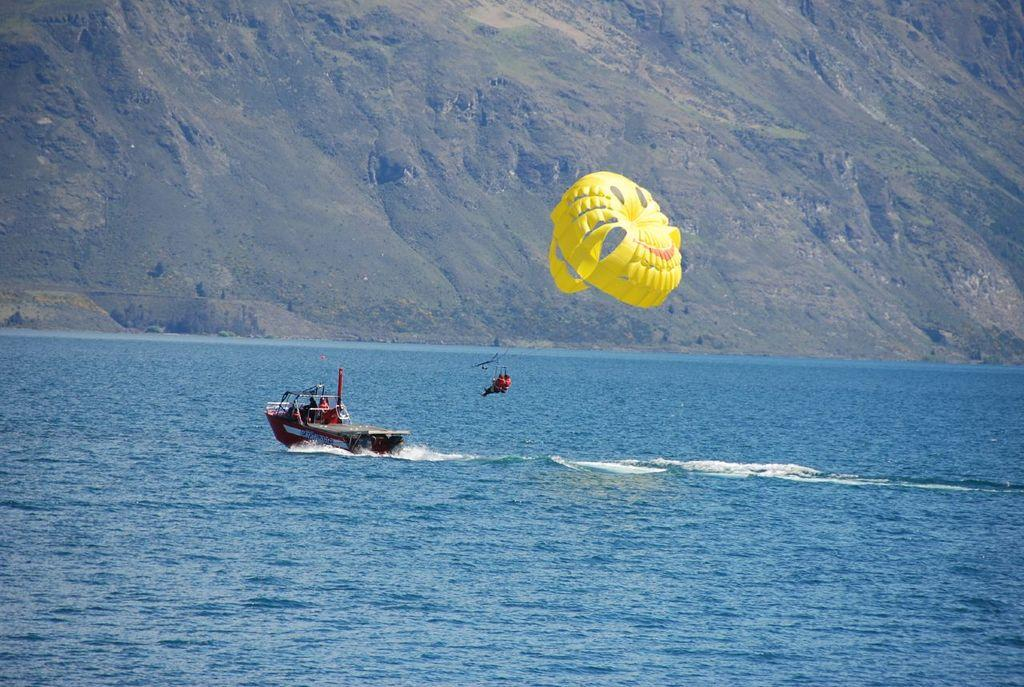What is the main feature of the image? There is water in the image. What is on the water? There is a boat on the water. Who is present in the image? There is a person in the image. What is in the air in the image? There is a yellow-colored parachute in the air. What can be seen in the distance in the image? There are mountains visible in the background of the image. What type of tray is being used toasted by the person in the image? There is no tray present in the image, and the person is not toasting anything. 